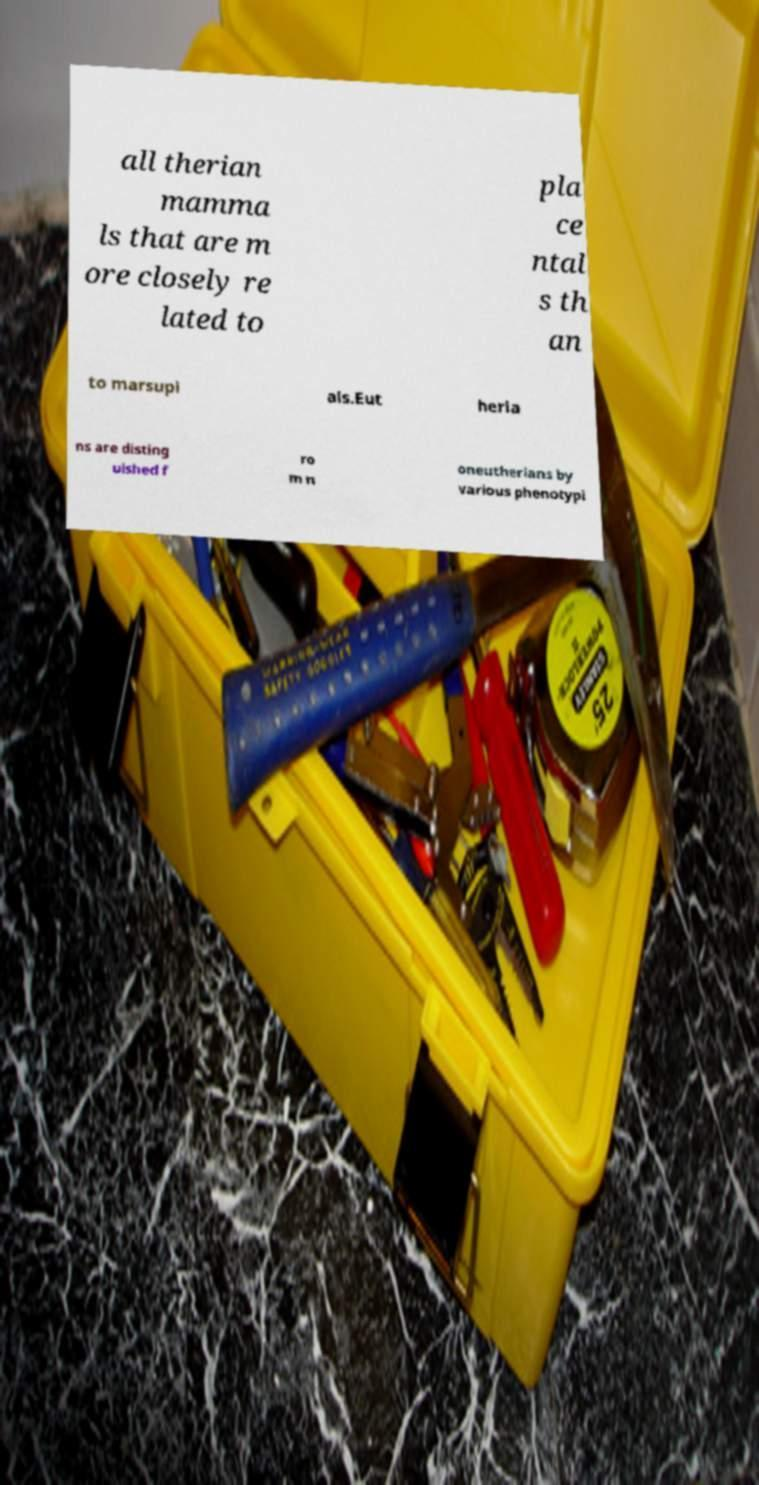Please read and relay the text visible in this image. What does it say? all therian mamma ls that are m ore closely re lated to pla ce ntal s th an to marsupi als.Eut heria ns are disting uished f ro m n oneutherians by various phenotypi 